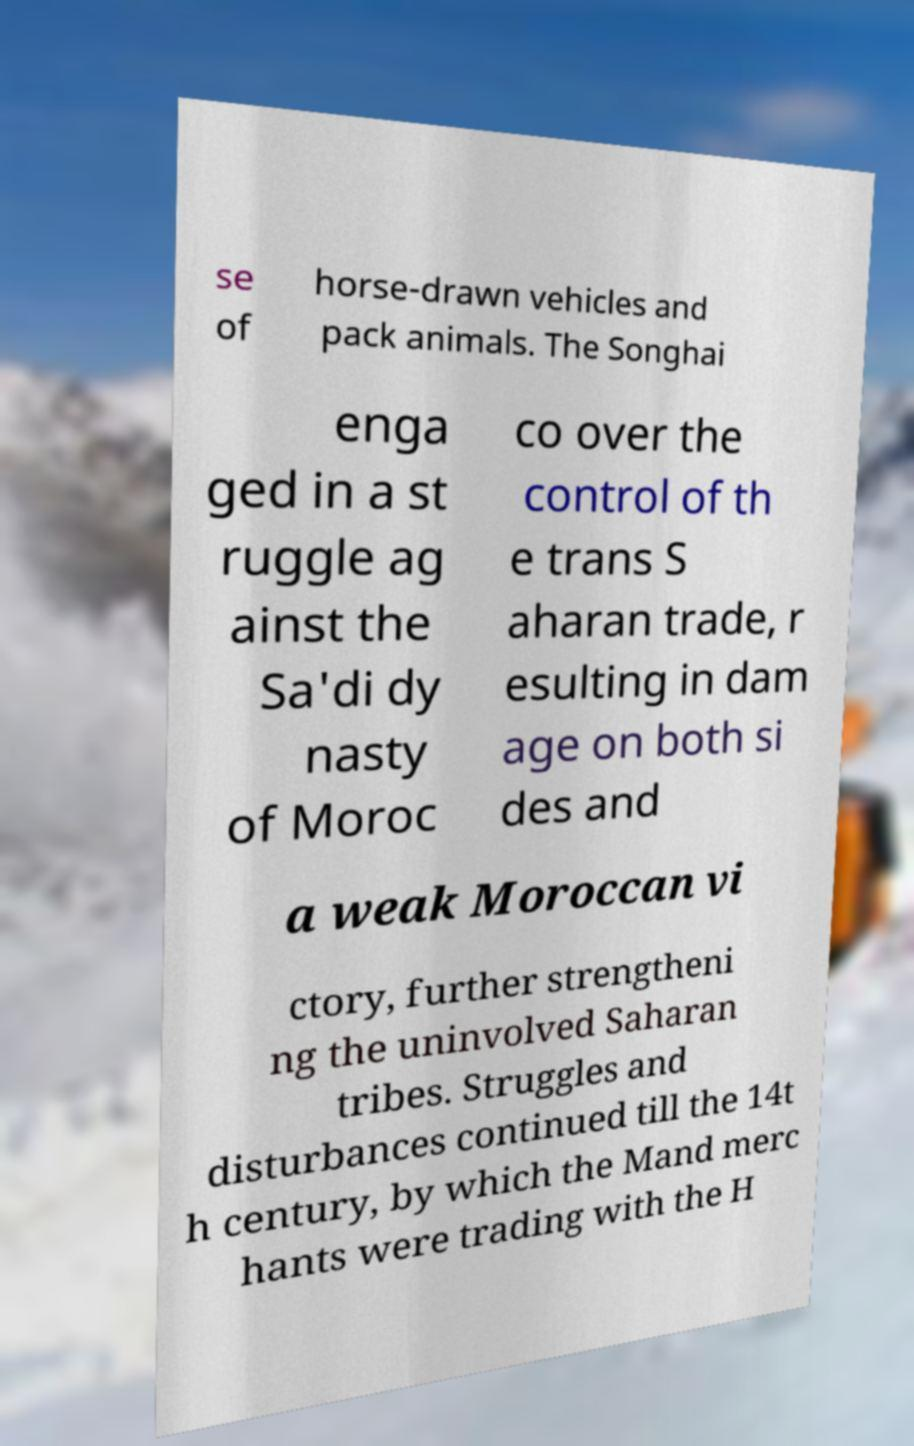There's text embedded in this image that I need extracted. Can you transcribe it verbatim? se of horse-drawn vehicles and pack animals. The Songhai enga ged in a st ruggle ag ainst the Sa'di dy nasty of Moroc co over the control of th e trans S aharan trade, r esulting in dam age on both si des and a weak Moroccan vi ctory, further strengtheni ng the uninvolved Saharan tribes. Struggles and disturbances continued till the 14t h century, by which the Mand merc hants were trading with the H 